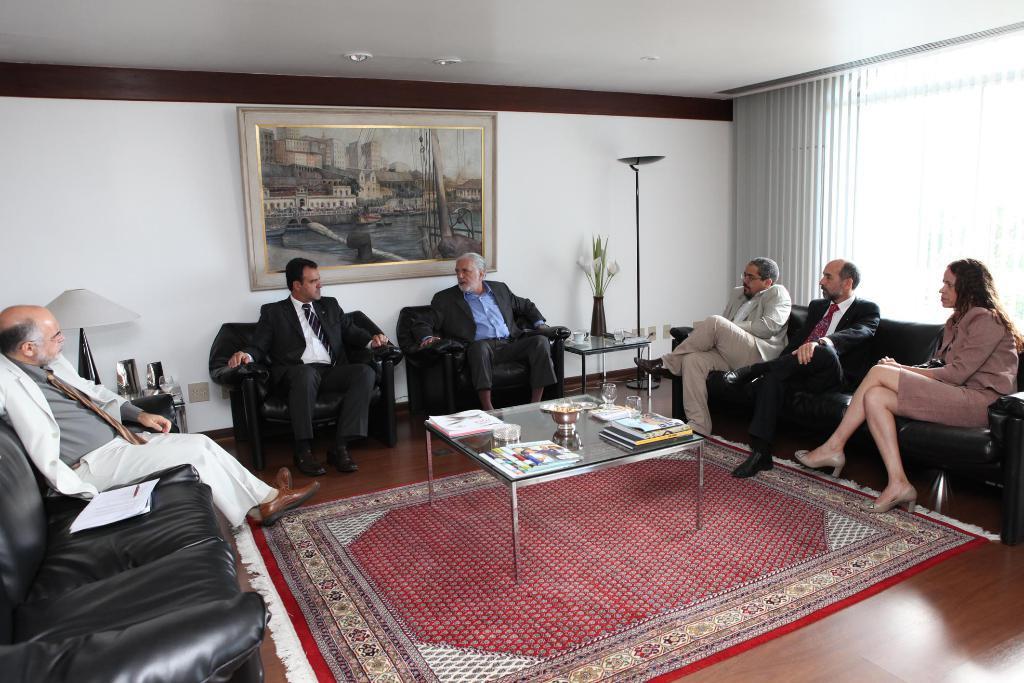Describe this image in one or two sentences. This picture is taken inside a room. There are few people sitting cozily on couch. The man to the left wore a white suit is having some papers beside him. There is a table in center and there are books and glasses placed on it. There is another table on which there is a flower vase and on the other side there is another table on which a lamp is placed. There is a beautiful big picture frame hanged on the wall. There are many buildings, sea and ships in the picture frame. There is carpet on the floor below the table in the center. There are lights to the ceiling. On the right of the image there are window blinds. 